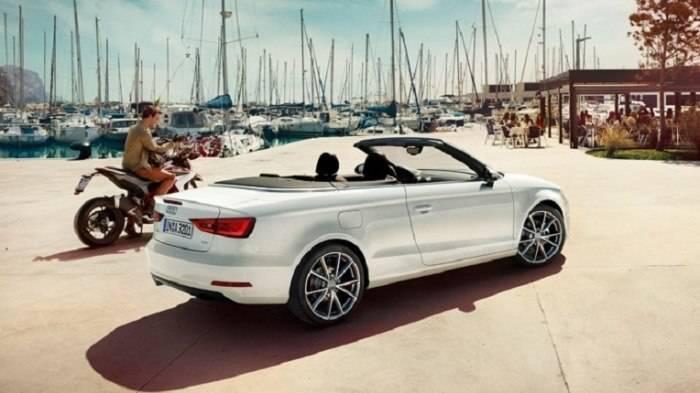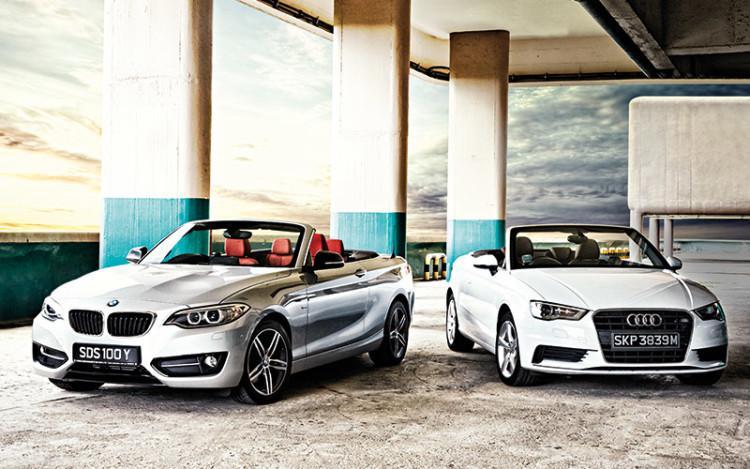The first image is the image on the left, the second image is the image on the right. Evaluate the accuracy of this statement regarding the images: "One image features a cream-colored convertible and a taupe convertible, both topless and parked in front of water.". Is it true? Answer yes or no. No. The first image is the image on the left, the second image is the image on the right. Evaluate the accuracy of this statement regarding the images: "The right image contains two convertible vehicles.". Is it true? Answer yes or no. Yes. 